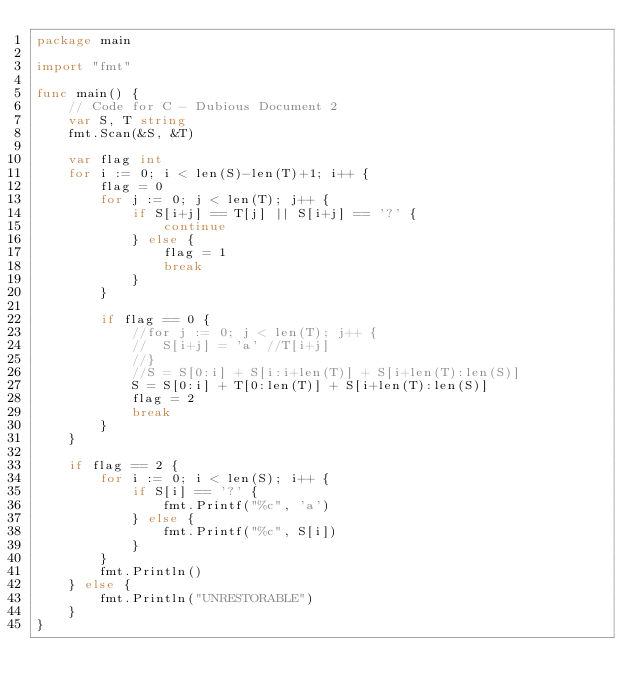Convert code to text. <code><loc_0><loc_0><loc_500><loc_500><_Go_>package main

import "fmt"

func main() {
	// Code for C - Dubious Document 2
	var S, T string
	fmt.Scan(&S, &T)

	var flag int
	for i := 0; i < len(S)-len(T)+1; i++ {
		flag = 0
		for j := 0; j < len(T); j++ {
			if S[i+j] == T[j] || S[i+j] == '?' {
				continue
			} else {
				flag = 1
				break
			}
		}

		if flag == 0 {
			//for j := 0; j < len(T); j++ {
			//	S[i+j] = 'a' //T[i+j]
			//}
			//S = S[0:i] + S[i:i+len(T)] + S[i+len(T):len(S)]
			S = S[0:i] + T[0:len(T)] + S[i+len(T):len(S)]
			flag = 2
			break
		}
	}

	if flag == 2 {
		for i := 0; i < len(S); i++ {
			if S[i] == '?' {
				fmt.Printf("%c", 'a')
			} else {
				fmt.Printf("%c", S[i])
			}
		}
		fmt.Println()
	} else {
		fmt.Println("UNRESTORABLE")
	}
}
</code> 